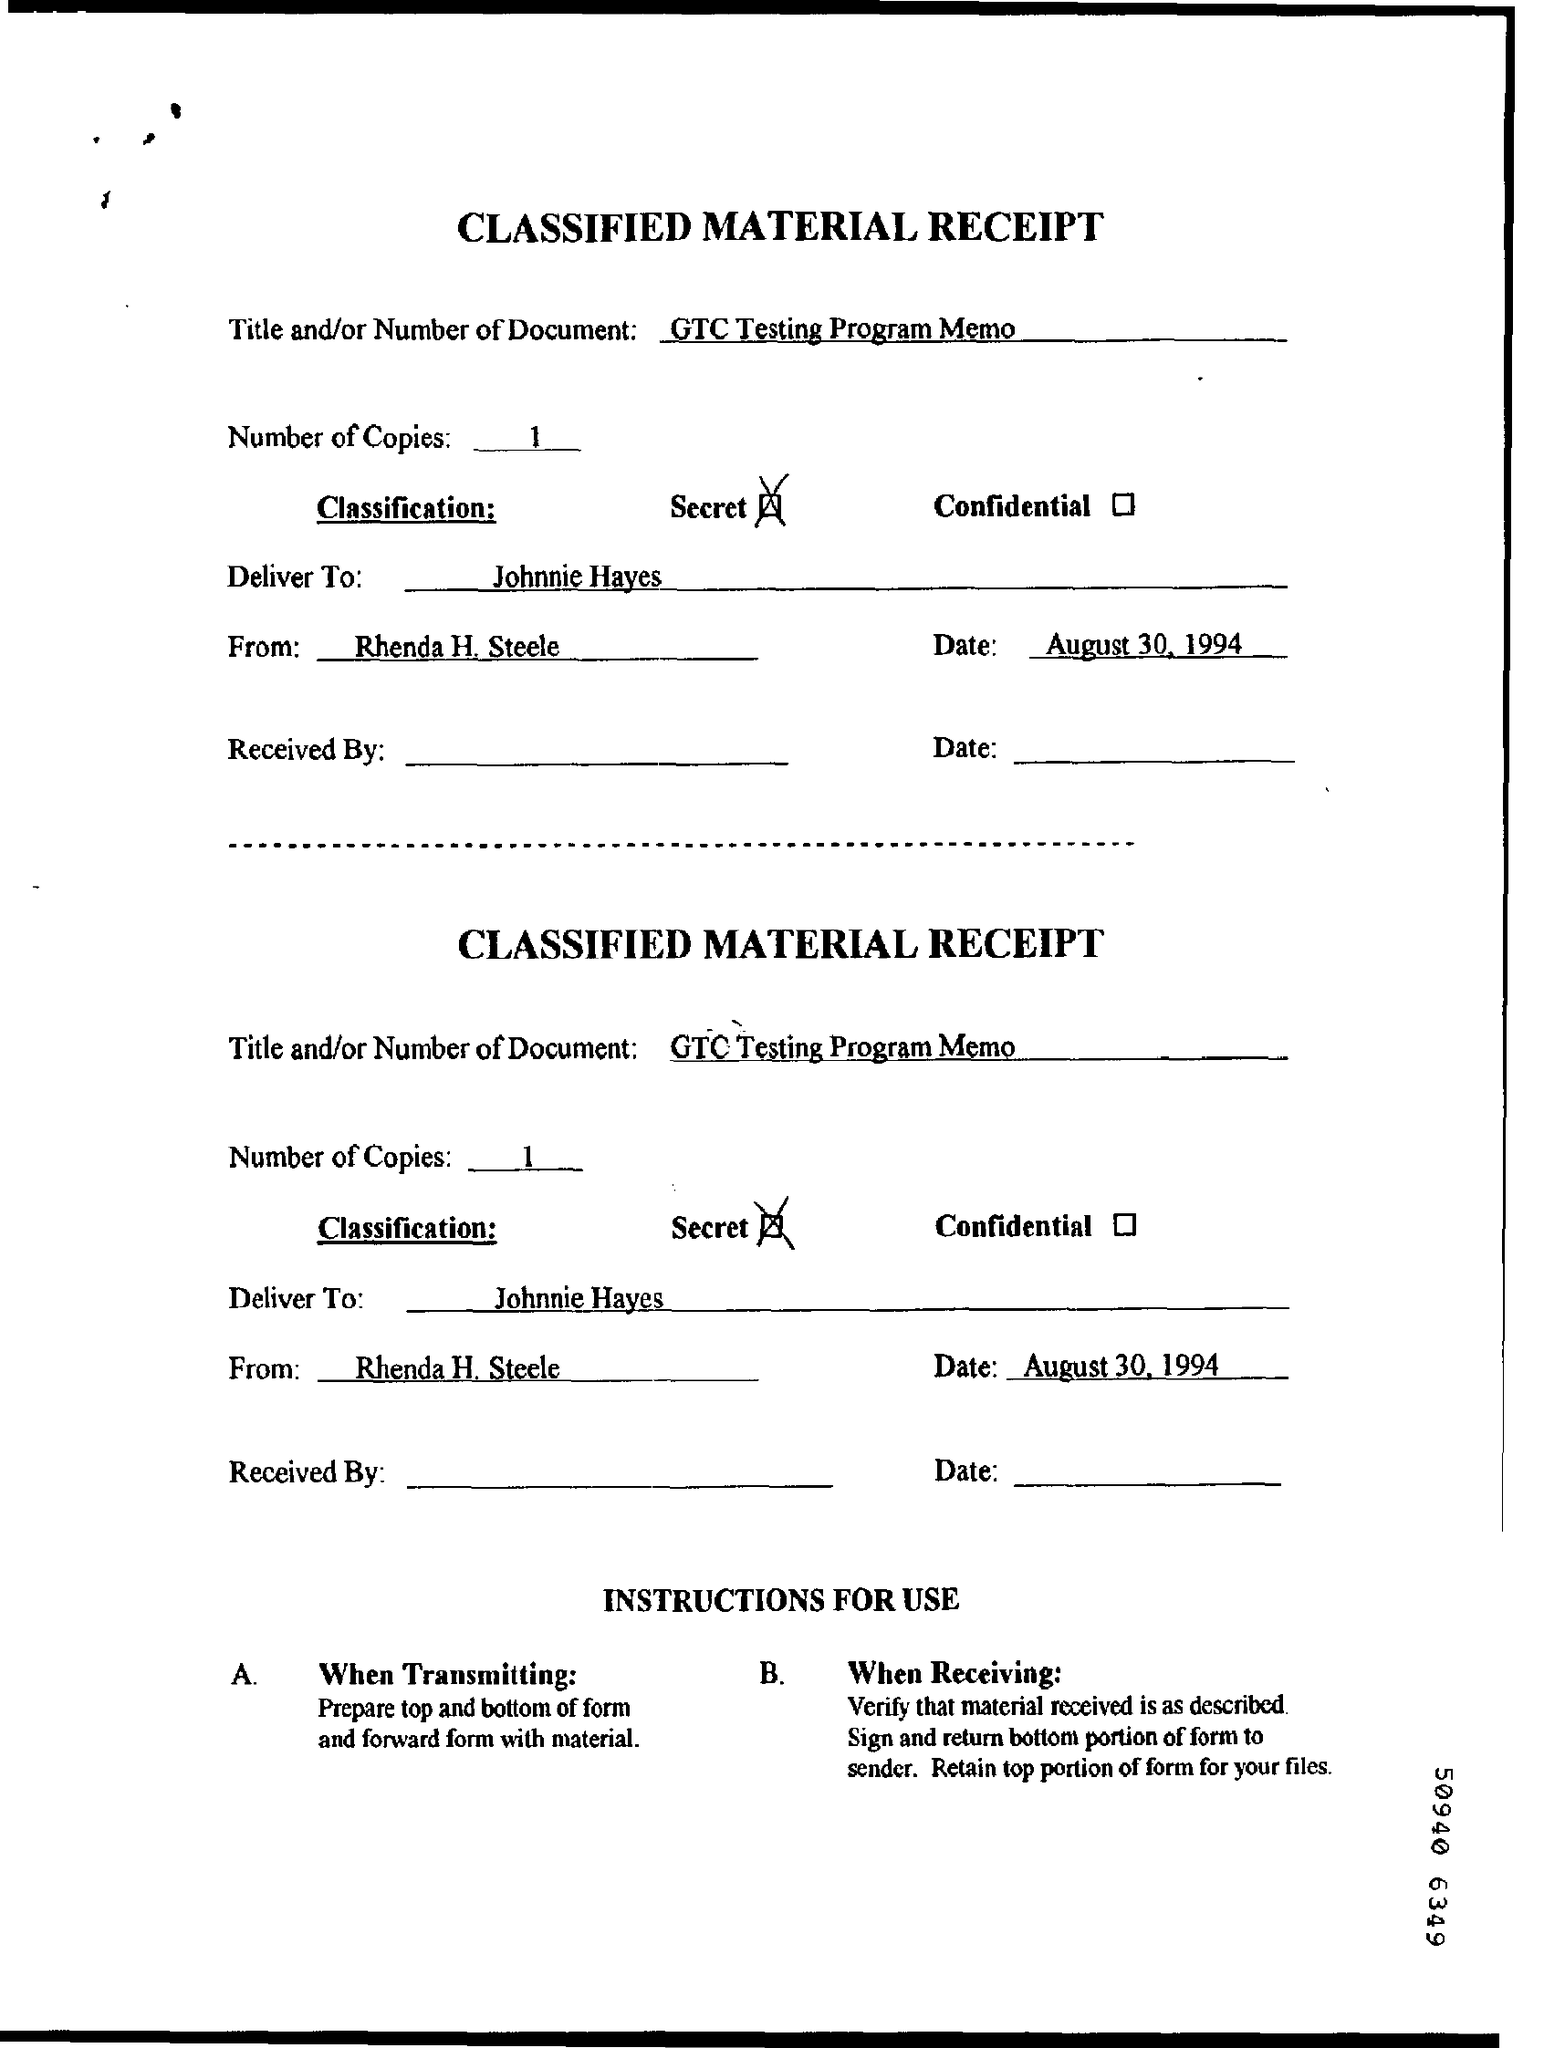Identify some key points in this picture. The total number of copies is 1. The memorandum is from Rhenda H. Steele. The information written in the title field is 'GT 